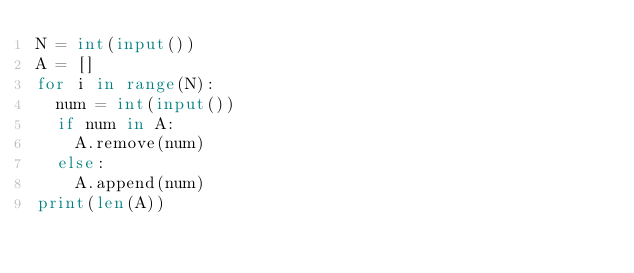<code> <loc_0><loc_0><loc_500><loc_500><_Python_>N = int(input())
A = []
for i in range(N):
  num = int(input())
  if num in A:
    A.remove(num)
  else:
    A.append(num)
print(len(A))</code> 